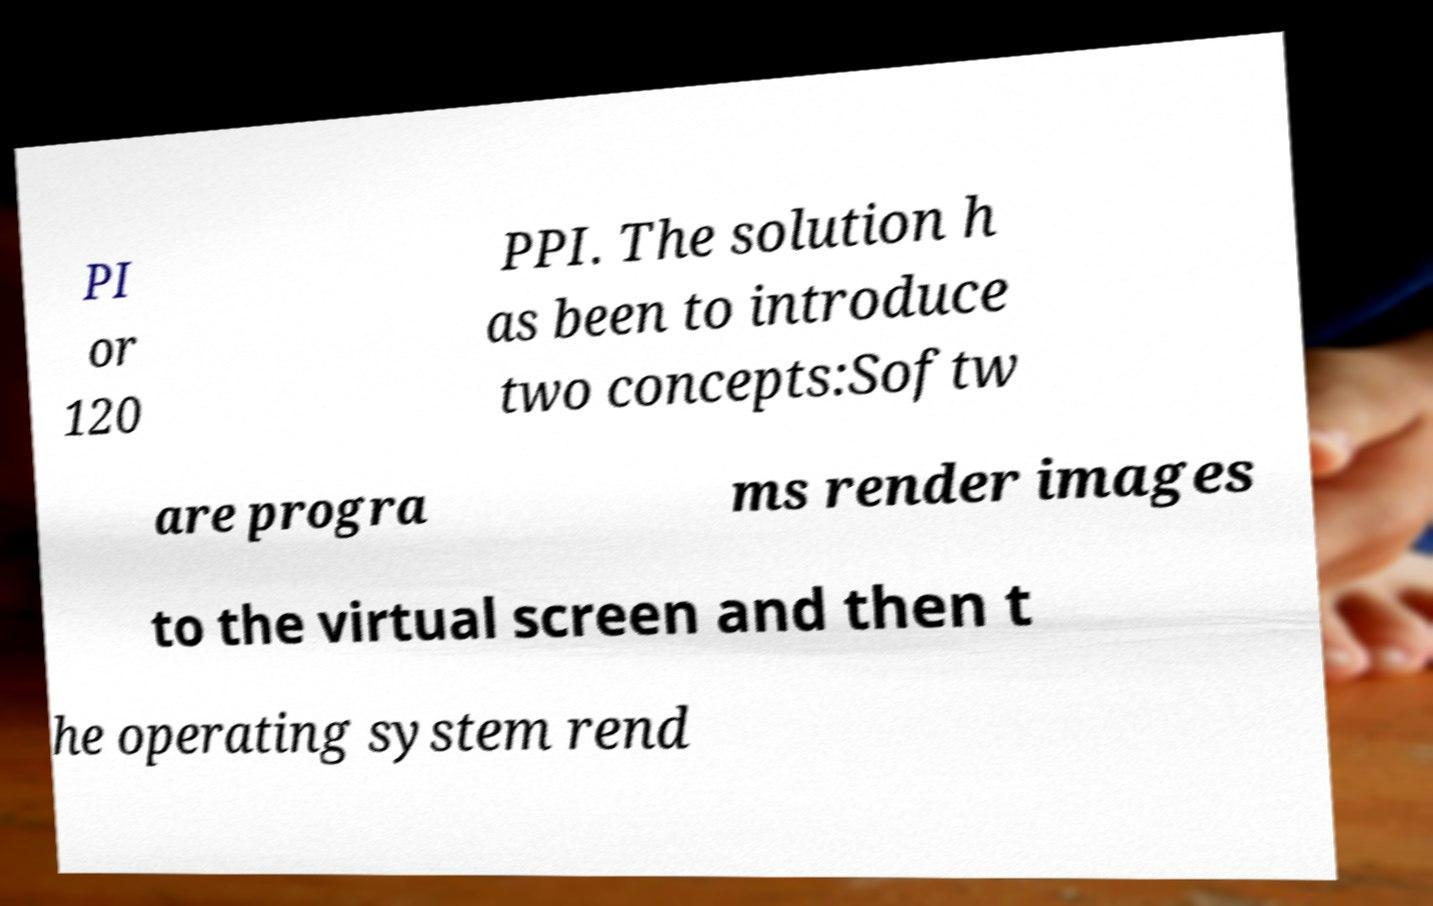Can you read and provide the text displayed in the image?This photo seems to have some interesting text. Can you extract and type it out for me? PI or 120 PPI. The solution h as been to introduce two concepts:Softw are progra ms render images to the virtual screen and then t he operating system rend 